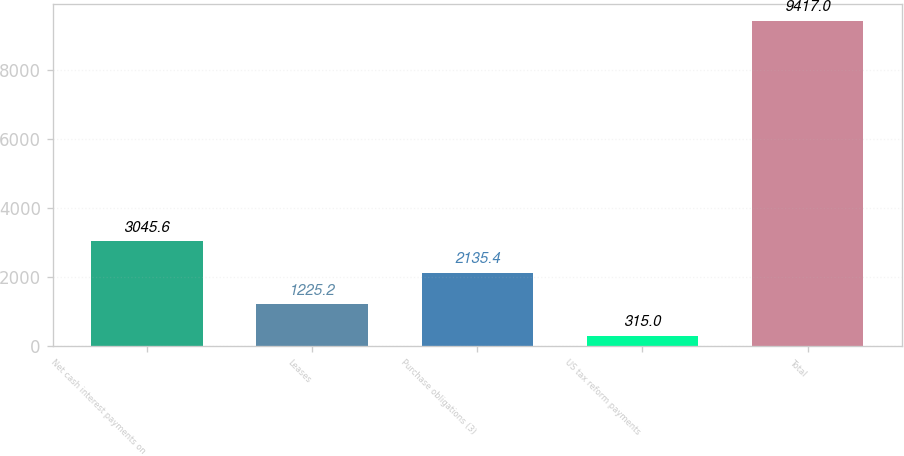Convert chart to OTSL. <chart><loc_0><loc_0><loc_500><loc_500><bar_chart><fcel>Net cash interest payments on<fcel>Leases<fcel>Purchase obligations (3)<fcel>US tax reform payments<fcel>Total<nl><fcel>3045.6<fcel>1225.2<fcel>2135.4<fcel>315<fcel>9417<nl></chart> 